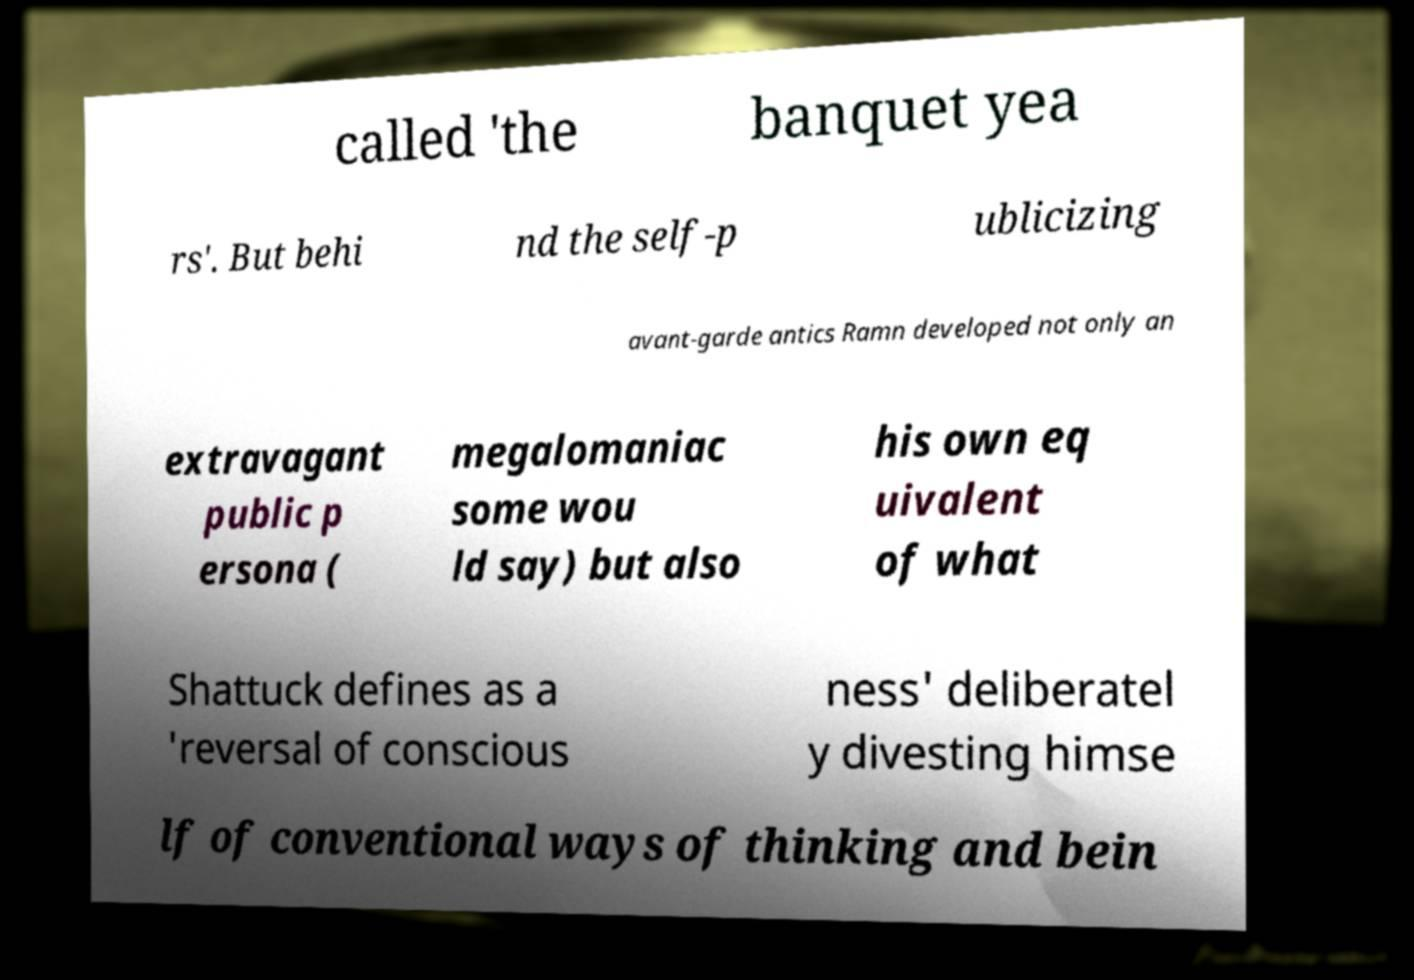There's text embedded in this image that I need extracted. Can you transcribe it verbatim? called 'the banquet yea rs'. But behi nd the self-p ublicizing avant-garde antics Ramn developed not only an extravagant public p ersona ( megalomaniac some wou ld say) but also his own eq uivalent of what Shattuck defines as a 'reversal of conscious ness' deliberatel y divesting himse lf of conventional ways of thinking and bein 